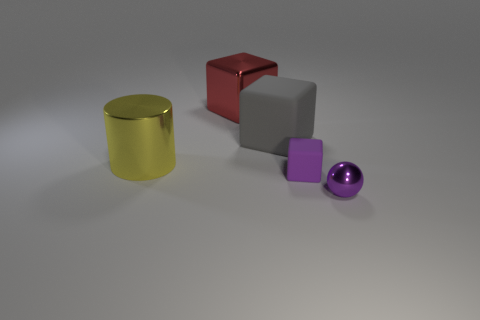Are these objects representing something specific, or are they just random shapes? The objects don't appear to represent anything specific; they seem to be a collection of random shapes, often used for 3D rendering and lighting tests to showcase how different surfaces interact with light. Could there be a symbolic interpretation of these shapes? While these shapes are typically used for technical purposes, one could imagine a symbolic interpretation where each shape represents an element of diversity or uniqueness, suggesting that despite differences in appearance and substance, they all coexist harmoniously within the same space. 